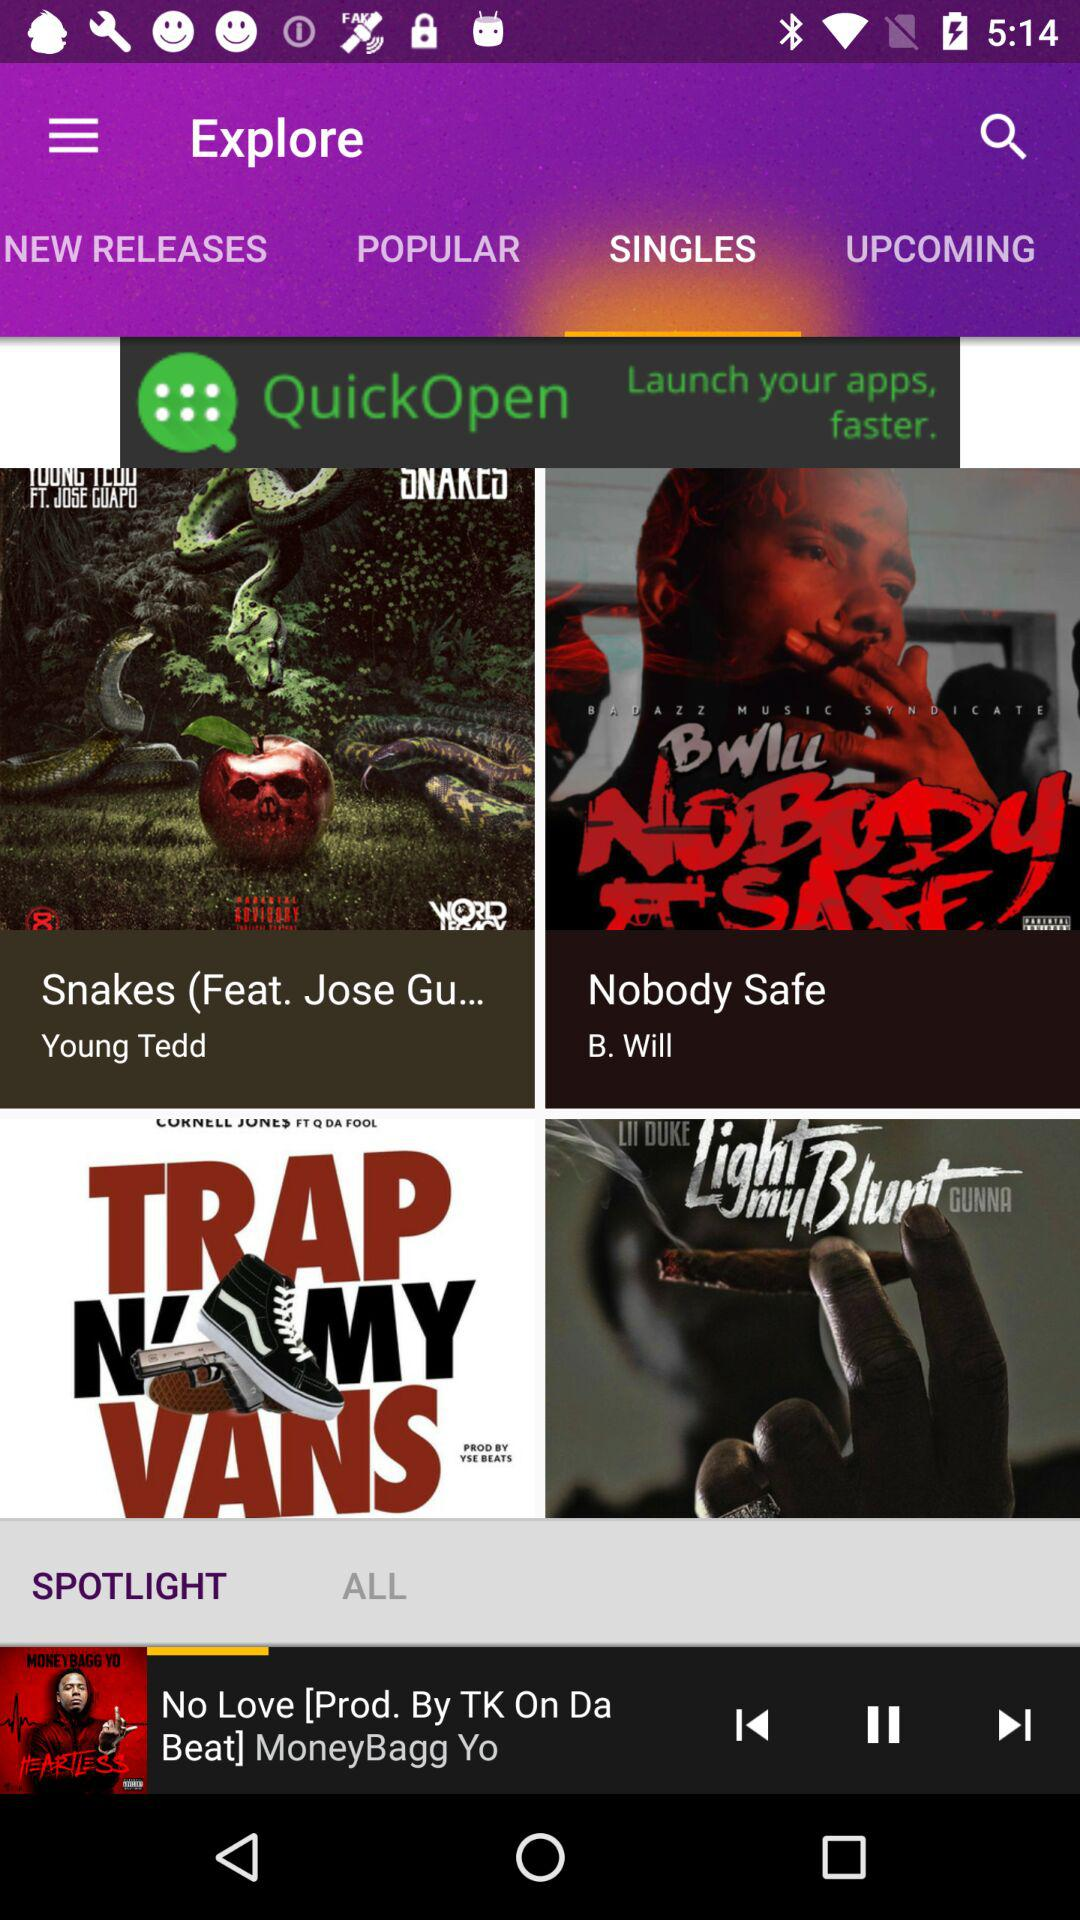Which tab is selected? The selected tabs are "SINGLES" and "SPOTLIGHT". 